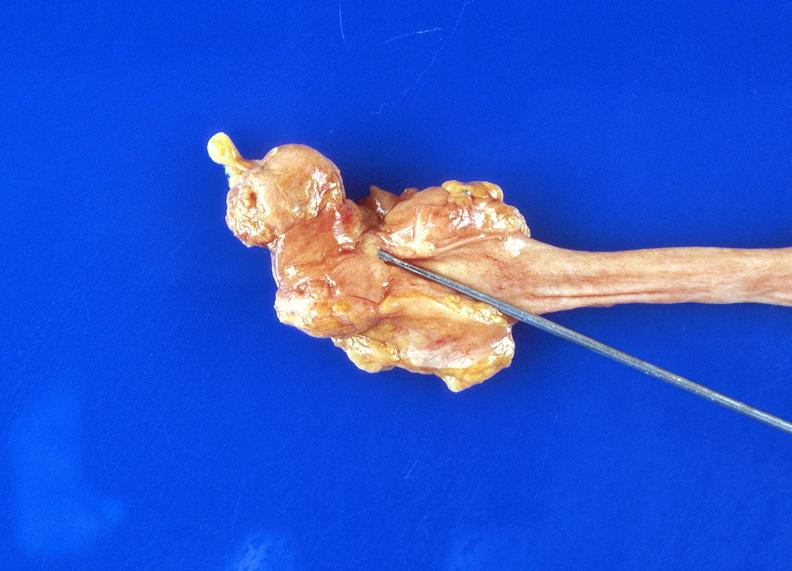does this fixed tissue show ureteral stricture?
Answer the question using a single word or phrase. No 